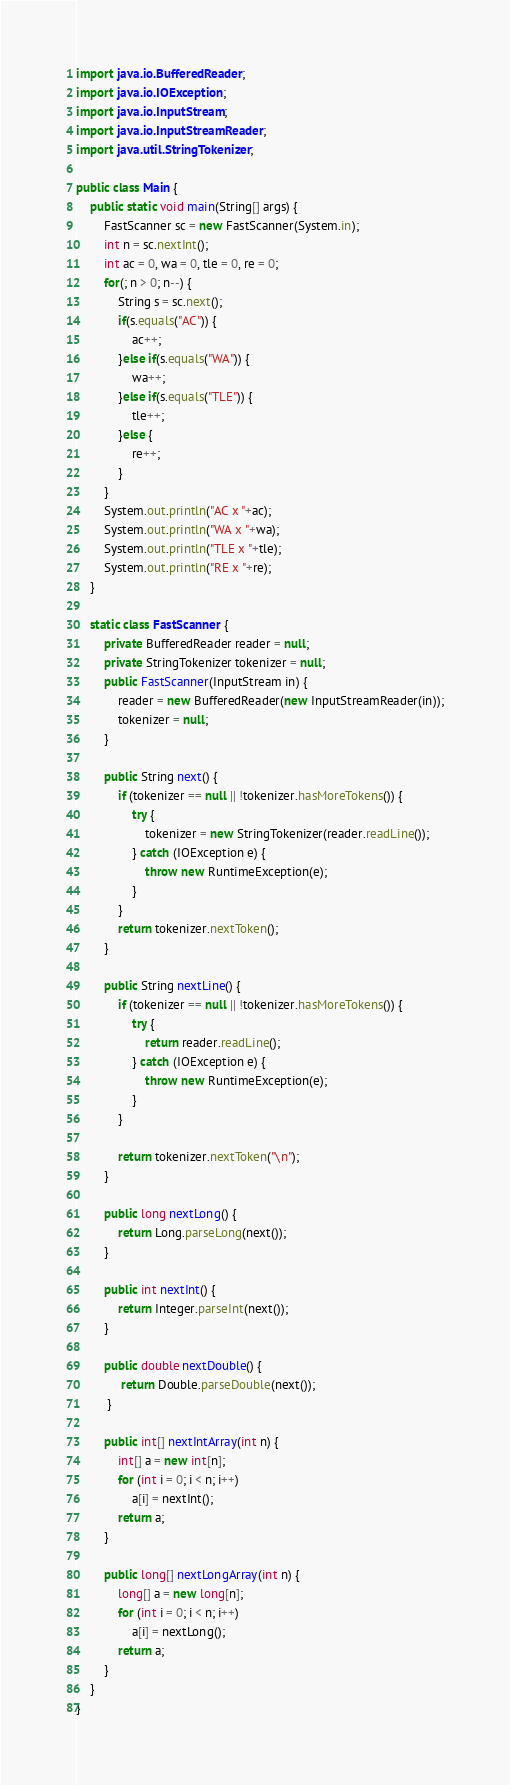<code> <loc_0><loc_0><loc_500><loc_500><_Java_>import java.io.BufferedReader;
import java.io.IOException;
import java.io.InputStream;
import java.io.InputStreamReader;
import java.util.StringTokenizer;

public class Main {
	public static void main(String[] args) {
		FastScanner sc = new FastScanner(System.in);
		int n = sc.nextInt();
		int ac = 0, wa = 0, tle = 0, re = 0;
		for(; n > 0; n--) {
			String s = sc.next();
			if(s.equals("AC")) {
				ac++;
			}else if(s.equals("WA")) {
				wa++;
			}else if(s.equals("TLE")) {
				tle++;
			}else {
				re++;
			}
		}
		System.out.println("AC x "+ac);
		System.out.println("WA x "+wa);
		System.out.println("TLE x "+tle);
		System.out.println("RE x "+re);
	}

	static class FastScanner {
		private BufferedReader reader = null;
	    private StringTokenizer tokenizer = null;
	    public FastScanner(InputStream in) {
	        reader = new BufferedReader(new InputStreamReader(in));
	        tokenizer = null;
	    }

	    public String next() {
	        if (tokenizer == null || !tokenizer.hasMoreTokens()) {
	            try {
	                tokenizer = new StringTokenizer(reader.readLine());
	            } catch (IOException e) {
	                throw new RuntimeException(e);
	            }
	        }
	        return tokenizer.nextToken();
	    }

	    public String nextLine() {
	        if (tokenizer == null || !tokenizer.hasMoreTokens()) {
	            try {
	                return reader.readLine();
	            } catch (IOException e) {
	                throw new RuntimeException(e);
	            }
	        }

	        return tokenizer.nextToken("\n");
	    }

	    public long nextLong() {
	        return Long.parseLong(next());
	    }

	    public int nextInt() {
	        return Integer.parseInt(next());
	    }

	    public double nextDouble() {
	         return Double.parseDouble(next());
	     }

	    public int[] nextIntArray(int n) {
	        int[] a = new int[n];
	        for (int i = 0; i < n; i++)
	            a[i] = nextInt();
	        return a;
	    }

	    public long[] nextLongArray(int n) {
	        long[] a = new long[n];
	        for (int i = 0; i < n; i++)
	            a[i] = nextLong();
	        return a;
	    }
	}
}
</code> 